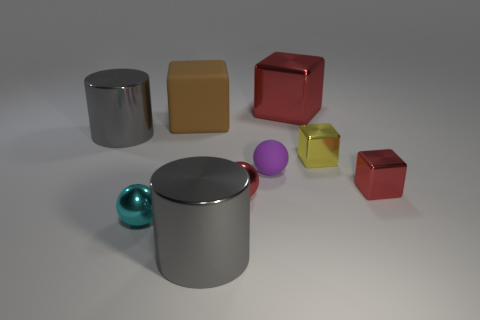How many red cubes must be subtracted to get 1 red cubes? 1 Subtract all tiny red blocks. How many blocks are left? 3 Add 1 big brown cylinders. How many objects exist? 10 Subtract all cyan balls. How many red cubes are left? 2 Subtract all purple balls. How many balls are left? 2 Subtract 1 cubes. How many cubes are left? 3 Subtract all red cubes. Subtract all red cylinders. How many cubes are left? 2 Subtract all tiny blocks. Subtract all big rubber cubes. How many objects are left? 6 Add 4 large matte objects. How many large matte objects are left? 5 Add 3 gray objects. How many gray objects exist? 5 